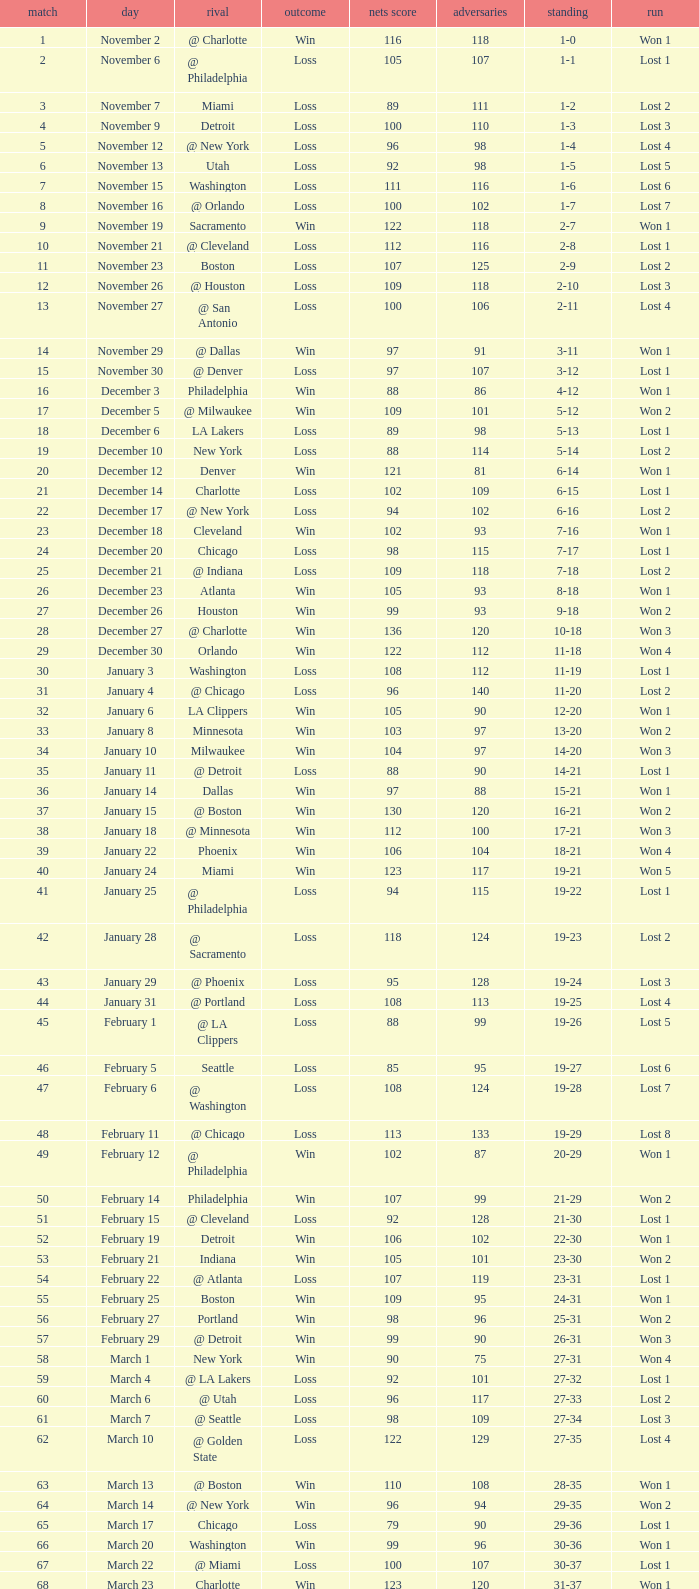Which opponent is from february 12? @ Philadelphia. 